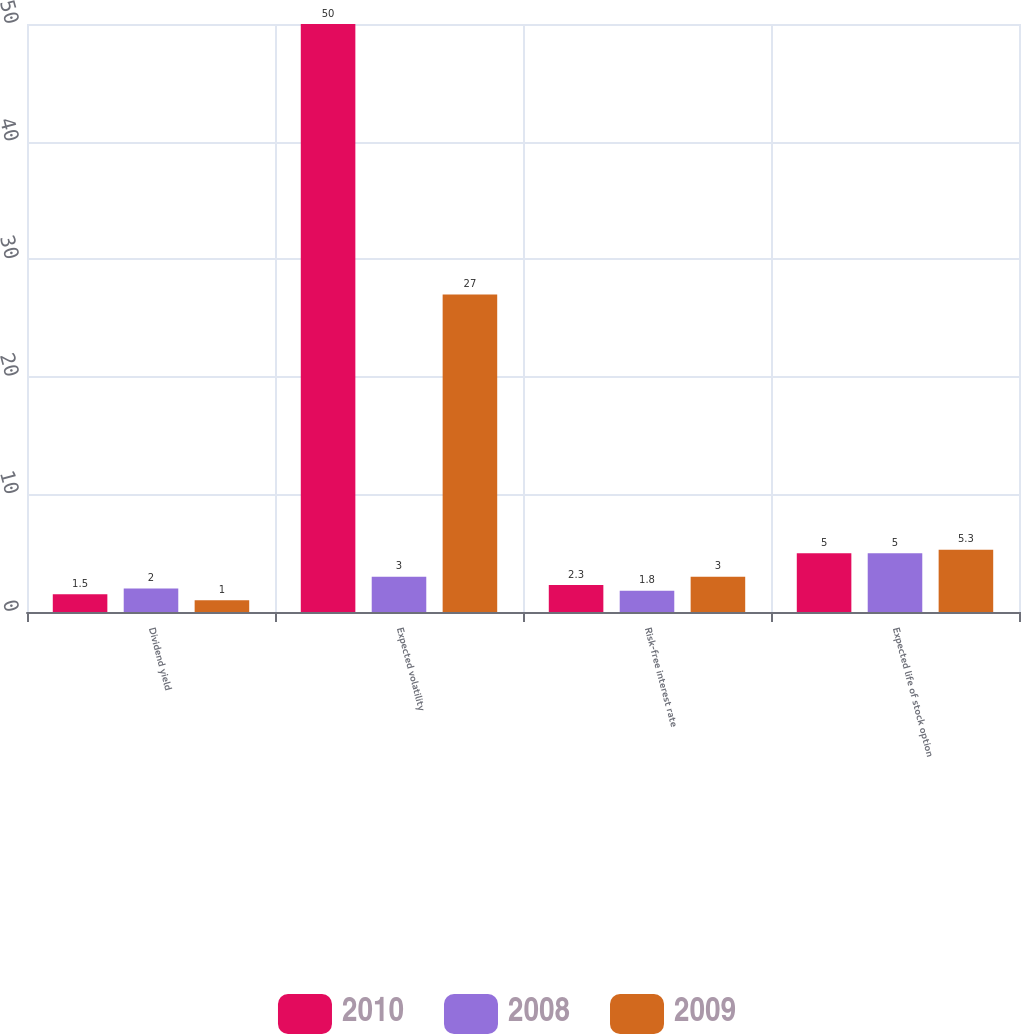<chart> <loc_0><loc_0><loc_500><loc_500><stacked_bar_chart><ecel><fcel>Dividend yield<fcel>Expected volatility<fcel>Risk-free interest rate<fcel>Expected life of stock option<nl><fcel>2010<fcel>1.5<fcel>50<fcel>2.3<fcel>5<nl><fcel>2008<fcel>2<fcel>3<fcel>1.8<fcel>5<nl><fcel>2009<fcel>1<fcel>27<fcel>3<fcel>5.3<nl></chart> 